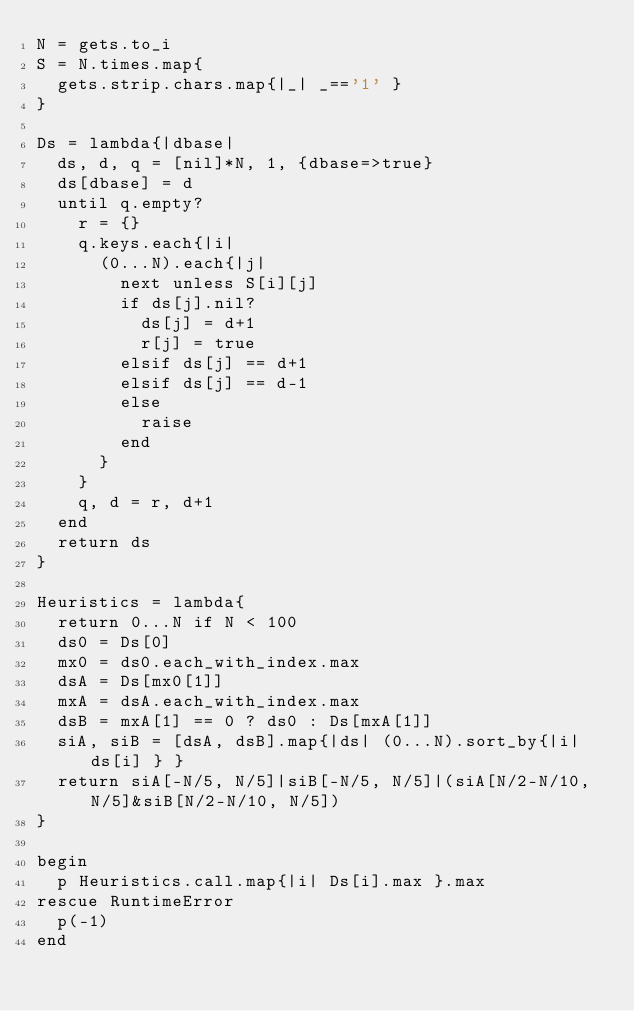Convert code to text. <code><loc_0><loc_0><loc_500><loc_500><_Ruby_>N = gets.to_i
S = N.times.map{
	gets.strip.chars.map{|_| _=='1' }
}

Ds = lambda{|dbase|
	ds, d, q = [nil]*N, 1, {dbase=>true}
	ds[dbase] = d
	until q.empty?
		r = {}
		q.keys.each{|i|
			(0...N).each{|j|
				next unless S[i][j]
				if ds[j].nil?
					ds[j] = d+1
					r[j] = true
				elsif ds[j] == d+1
				elsif ds[j] == d-1
				else
					raise
				end
			}
		}
		q, d = r, d+1
	end
	return ds
}

Heuristics = lambda{
	return 0...N if N < 100
	ds0 = Ds[0]
	mx0 = ds0.each_with_index.max
	dsA = Ds[mx0[1]]
	mxA = dsA.each_with_index.max
	dsB = mxA[1] == 0 ? ds0 : Ds[mxA[1]]
	siA, siB = [dsA, dsB].map{|ds| (0...N).sort_by{|i| ds[i] } }
	return siA[-N/5, N/5]|siB[-N/5, N/5]|(siA[N/2-N/10, N/5]&siB[N/2-N/10, N/5])
}

begin
	p Heuristics.call.map{|i| Ds[i].max }.max
rescue RuntimeError
	p(-1)
end
</code> 